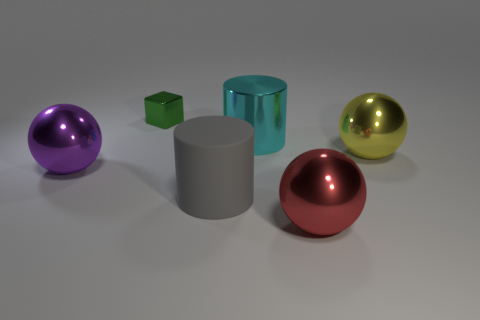Add 4 large brown metallic blocks. How many objects exist? 10 Subtract all cylinders. How many objects are left? 4 Add 5 large green shiny cylinders. How many large green shiny cylinders exist? 5 Subtract 1 cyan cylinders. How many objects are left? 5 Subtract all tiny shiny cubes. Subtract all metal cubes. How many objects are left? 4 Add 2 big cylinders. How many big cylinders are left? 4 